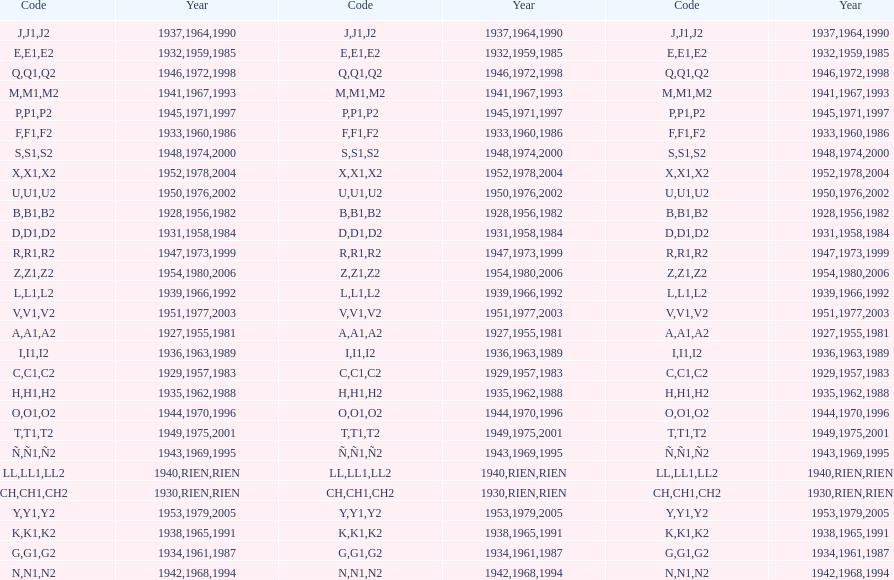Number of codes containing a 2? 28. Help me parse the entirety of this table. {'header': ['Code', 'Year', 'Code', 'Year', 'Code', 'Year'], 'rows': [['J', '1937', 'J1', '1964', 'J2', '1990'], ['E', '1932', 'E1', '1959', 'E2', '1985'], ['Q', '1946', 'Q1', '1972', 'Q2', '1998'], ['M', '1941', 'M1', '1967', 'M2', '1993'], ['P', '1945', 'P1', '1971', 'P2', '1997'], ['F', '1933', 'F1', '1960', 'F2', '1986'], ['S', '1948', 'S1', '1974', 'S2', '2000'], ['X', '1952', 'X1', '1978', 'X2', '2004'], ['U', '1950', 'U1', '1976', 'U2', '2002'], ['B', '1928', 'B1', '1956', 'B2', '1982'], ['D', '1931', 'D1', '1958', 'D2', '1984'], ['R', '1947', 'R1', '1973', 'R2', '1999'], ['Z', '1954', 'Z1', '1980', 'Z2', '2006'], ['L', '1939', 'L1', '1966', 'L2', '1992'], ['V', '1951', 'V1', '1977', 'V2', '2003'], ['A', '1927', 'A1', '1955', 'A2', '1981'], ['I', '1936', 'I1', '1963', 'I2', '1989'], ['C', '1929', 'C1', '1957', 'C2', '1983'], ['H', '1935', 'H1', '1962', 'H2', '1988'], ['O', '1944', 'O1', '1970', 'O2', '1996'], ['T', '1949', 'T1', '1975', 'T2', '2001'], ['Ñ', '1943', 'Ñ1', '1969', 'Ñ2', '1995'], ['LL', '1940', 'LL1', 'RIEN', 'LL2', 'RIEN'], ['CH', '1930', 'CH1', 'RIEN', 'CH2', 'RIEN'], ['Y', '1953', 'Y1', '1979', 'Y2', '2005'], ['K', '1938', 'K1', '1965', 'K2', '1991'], ['G', '1934', 'G1', '1961', 'G2', '1987'], ['N', '1942', 'N1', '1968', 'N2', '1994']]} 